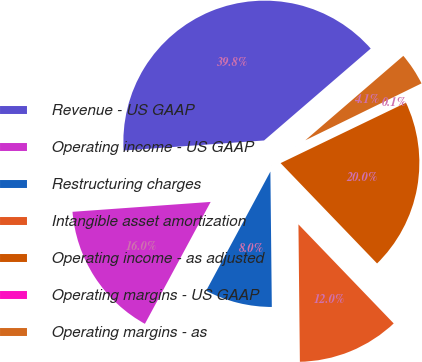Convert chart. <chart><loc_0><loc_0><loc_500><loc_500><pie_chart><fcel>Revenue - US GAAP<fcel>Operating income - US GAAP<fcel>Restructuring charges<fcel>Intangible asset amortization<fcel>Operating income - as adjusted<fcel>Operating margins - US GAAP<fcel>Operating margins - as<nl><fcel>39.82%<fcel>15.99%<fcel>8.04%<fcel>12.02%<fcel>19.96%<fcel>0.1%<fcel>4.07%<nl></chart> 